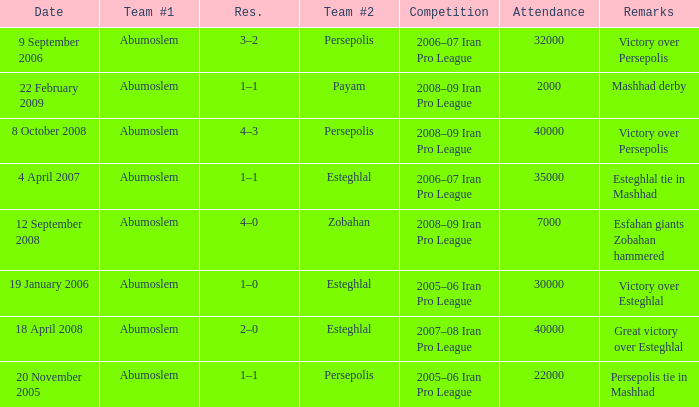Who was the leading team on 9th september 2006? Abumoslem. 